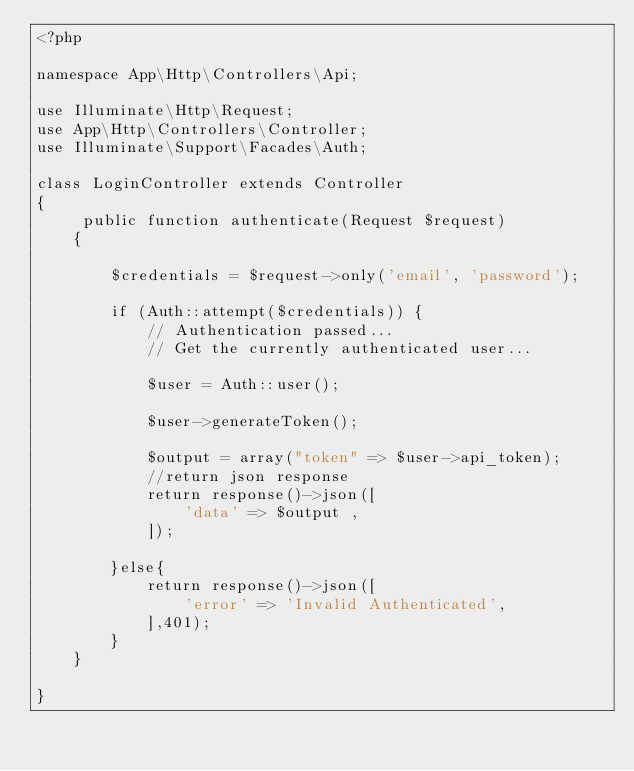Convert code to text. <code><loc_0><loc_0><loc_500><loc_500><_PHP_><?php

namespace App\Http\Controllers\Api;

use Illuminate\Http\Request;
use App\Http\Controllers\Controller;
use Illuminate\Support\Facades\Auth;

class LoginController extends Controller
{
     public function authenticate(Request $request)
    {
        
        $credentials = $request->only('email', 'password');
     
        if (Auth::attempt($credentials)) {
            // Authentication passed...
            // Get the currently authenticated user...
   
            $user = Auth::user();
                    
            $user->generateToken();
            
            $output = array("token" => $user->api_token);
            //return json response
            return response()->json([
                'data' => $output ,
            ]);
           
        }else{
            return response()->json([
                'error' => 'Invalid Authenticated',
            ],401);
        }
    }

}
</code> 